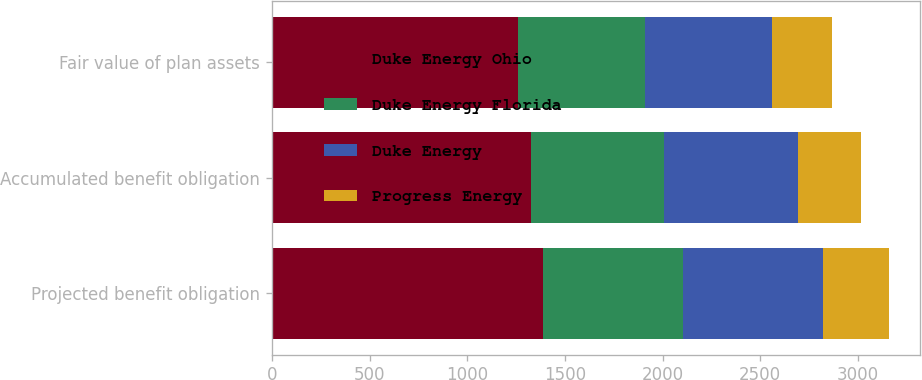Convert chart to OTSL. <chart><loc_0><loc_0><loc_500><loc_500><stacked_bar_chart><ecel><fcel>Projected benefit obligation<fcel>Accumulated benefit obligation<fcel>Fair value of plan assets<nl><fcel>Duke Energy Ohio<fcel>1386<fcel>1326<fcel>1260<nl><fcel>Duke Energy Florida<fcel>718<fcel>683<fcel>650<nl><fcel>Duke Energy<fcel>718<fcel>683<fcel>650<nl><fcel>Progress Energy<fcel>337<fcel>326<fcel>308<nl></chart> 